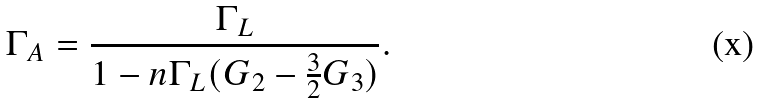Convert formula to latex. <formula><loc_0><loc_0><loc_500><loc_500>\Gamma _ { A } = \frac { \Gamma _ { L } } { 1 - n \Gamma _ { L } ( G _ { 2 } - \frac { 3 } { 2 } G _ { 3 } ) } .</formula> 